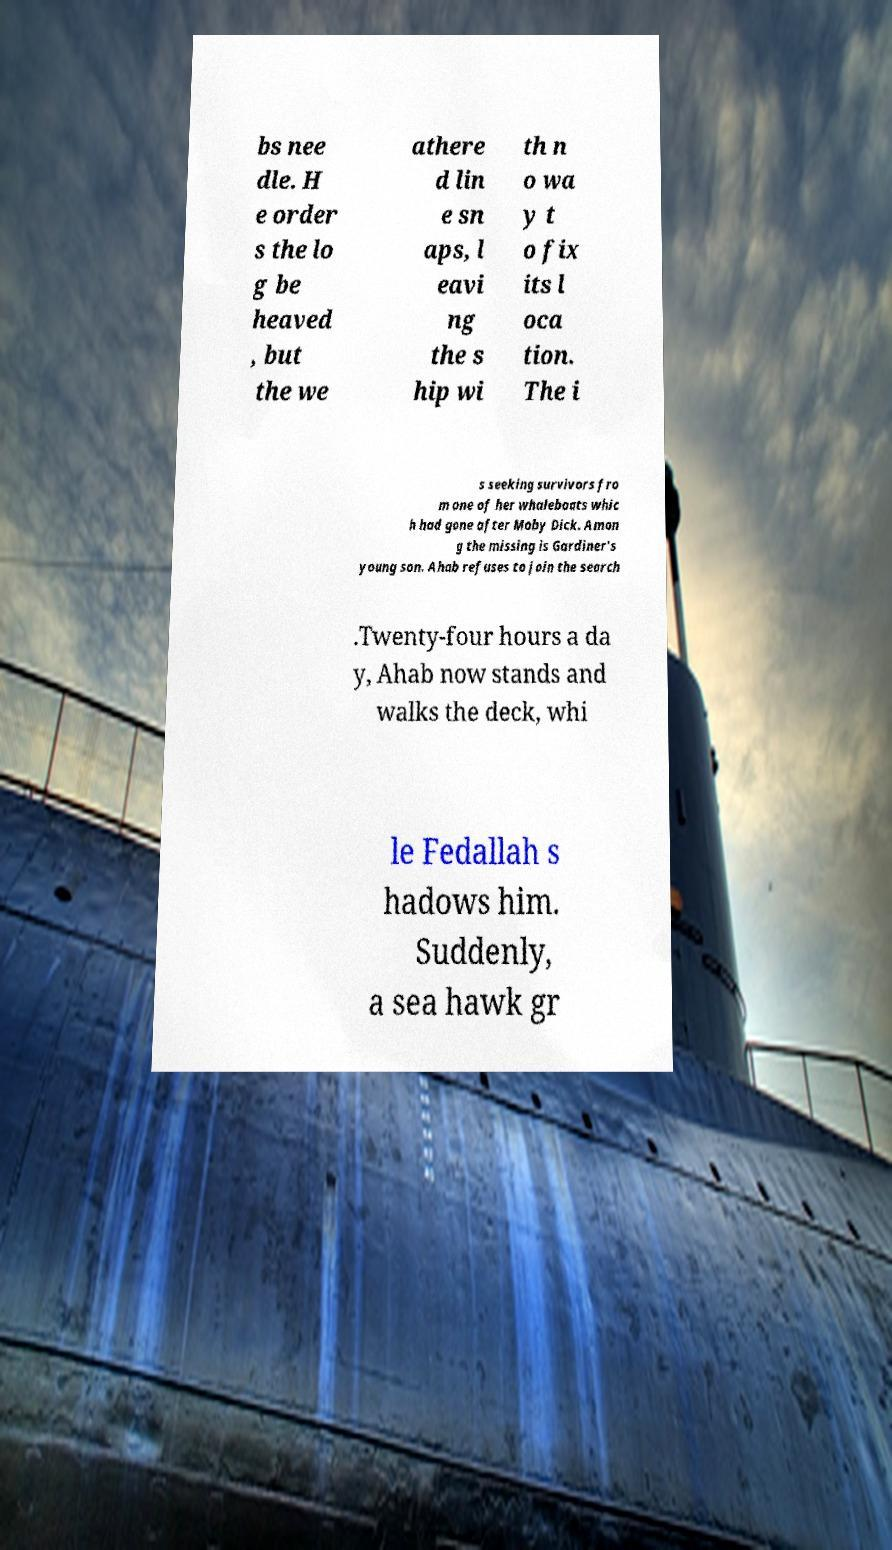Please identify and transcribe the text found in this image. bs nee dle. H e order s the lo g be heaved , but the we athere d lin e sn aps, l eavi ng the s hip wi th n o wa y t o fix its l oca tion. The i s seeking survivors fro m one of her whaleboats whic h had gone after Moby Dick. Amon g the missing is Gardiner's young son. Ahab refuses to join the search .Twenty-four hours a da y, Ahab now stands and walks the deck, whi le Fedallah s hadows him. Suddenly, a sea hawk gr 